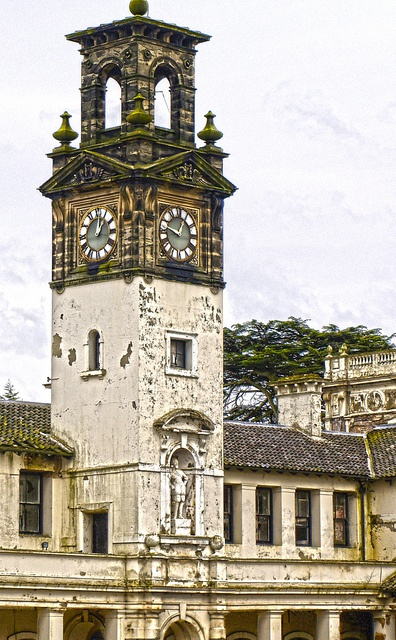Describe the objects in this image and their specific colors. I can see clock in lavender, gray, white, darkgray, and black tones and clock in lavender, white, gray, and darkgray tones in this image. 